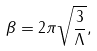Convert formula to latex. <formula><loc_0><loc_0><loc_500><loc_500>\beta = 2 \pi \sqrt { \frac { 3 } { \Lambda } } ,</formula> 